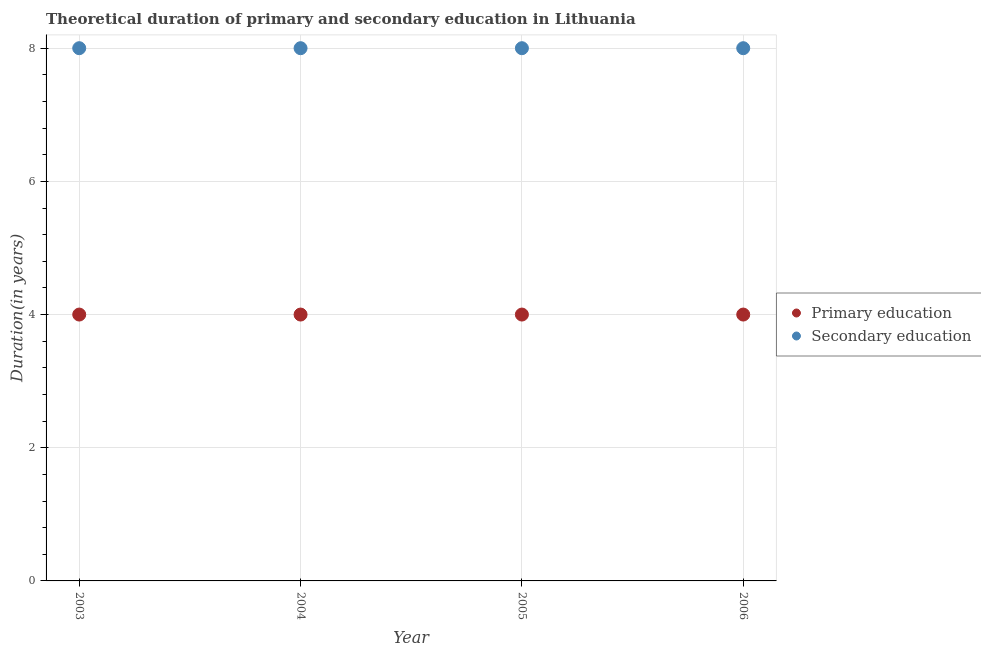How many different coloured dotlines are there?
Provide a succinct answer. 2. Is the number of dotlines equal to the number of legend labels?
Provide a short and direct response. Yes. What is the duration of secondary education in 2006?
Ensure brevity in your answer.  8. Across all years, what is the maximum duration of primary education?
Offer a very short reply. 4. Across all years, what is the minimum duration of primary education?
Offer a very short reply. 4. What is the total duration of secondary education in the graph?
Provide a succinct answer. 32. What is the difference between the duration of secondary education in 2005 and the duration of primary education in 2004?
Offer a very short reply. 4. In the year 2006, what is the difference between the duration of secondary education and duration of primary education?
Give a very brief answer. 4. What is the ratio of the duration of secondary education in 2003 to that in 2005?
Provide a short and direct response. 1. Is the duration of primary education in 2003 less than that in 2006?
Your answer should be compact. No. What is the difference between the highest and the second highest duration of secondary education?
Offer a terse response. 0. Is the sum of the duration of secondary education in 2003 and 2004 greater than the maximum duration of primary education across all years?
Offer a very short reply. Yes. Does the duration of primary education monotonically increase over the years?
Provide a short and direct response. No. Is the duration of secondary education strictly less than the duration of primary education over the years?
Provide a short and direct response. No. What is the difference between two consecutive major ticks on the Y-axis?
Your response must be concise. 2. Does the graph contain grids?
Provide a short and direct response. Yes. Where does the legend appear in the graph?
Provide a short and direct response. Center right. What is the title of the graph?
Give a very brief answer. Theoretical duration of primary and secondary education in Lithuania. What is the label or title of the Y-axis?
Keep it short and to the point. Duration(in years). What is the Duration(in years) of Secondary education in 2003?
Your response must be concise. 8. What is the Duration(in years) of Secondary education in 2004?
Make the answer very short. 8. What is the Duration(in years) in Primary education in 2005?
Your answer should be very brief. 4. What is the Duration(in years) in Secondary education in 2005?
Your answer should be compact. 8. What is the Duration(in years) of Secondary education in 2006?
Ensure brevity in your answer.  8. What is the total Duration(in years) of Primary education in the graph?
Give a very brief answer. 16. What is the total Duration(in years) of Secondary education in the graph?
Provide a succinct answer. 32. What is the difference between the Duration(in years) in Primary education in 2003 and that in 2005?
Your answer should be very brief. 0. What is the difference between the Duration(in years) of Secondary education in 2003 and that in 2006?
Provide a succinct answer. 0. What is the difference between the Duration(in years) of Secondary education in 2004 and that in 2006?
Your answer should be compact. 0. What is the difference between the Duration(in years) in Primary education in 2005 and that in 2006?
Make the answer very short. 0. What is the difference between the Duration(in years) in Primary education in 2003 and the Duration(in years) in Secondary education in 2004?
Your answer should be compact. -4. What is the difference between the Duration(in years) in Primary education in 2003 and the Duration(in years) in Secondary education in 2006?
Your answer should be compact. -4. What is the difference between the Duration(in years) in Primary education in 2004 and the Duration(in years) in Secondary education in 2005?
Your answer should be compact. -4. What is the difference between the Duration(in years) of Primary education in 2004 and the Duration(in years) of Secondary education in 2006?
Offer a terse response. -4. What is the average Duration(in years) of Primary education per year?
Your response must be concise. 4. What is the average Duration(in years) of Secondary education per year?
Give a very brief answer. 8. What is the ratio of the Duration(in years) in Primary education in 2003 to that in 2004?
Offer a very short reply. 1. What is the ratio of the Duration(in years) of Secondary education in 2003 to that in 2004?
Offer a very short reply. 1. What is the ratio of the Duration(in years) of Primary education in 2003 to that in 2005?
Your response must be concise. 1. What is the ratio of the Duration(in years) of Primary education in 2003 to that in 2006?
Ensure brevity in your answer.  1. What is the ratio of the Duration(in years) in Secondary education in 2004 to that in 2005?
Offer a very short reply. 1. What is the ratio of the Duration(in years) of Secondary education in 2004 to that in 2006?
Keep it short and to the point. 1. What is the ratio of the Duration(in years) in Secondary education in 2005 to that in 2006?
Offer a terse response. 1. What is the difference between the highest and the second highest Duration(in years) in Primary education?
Provide a succinct answer. 0. What is the difference between the highest and the second highest Duration(in years) of Secondary education?
Provide a succinct answer. 0. What is the difference between the highest and the lowest Duration(in years) in Secondary education?
Provide a succinct answer. 0. 